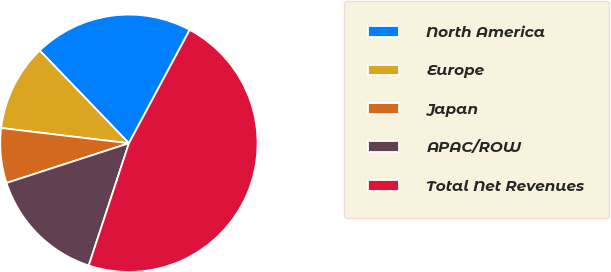Convert chart to OTSL. <chart><loc_0><loc_0><loc_500><loc_500><pie_chart><fcel>North America<fcel>Europe<fcel>Japan<fcel>APAC/ROW<fcel>Total Net Revenues<nl><fcel>20.02%<fcel>10.92%<fcel>6.88%<fcel>14.95%<fcel>47.23%<nl></chart> 